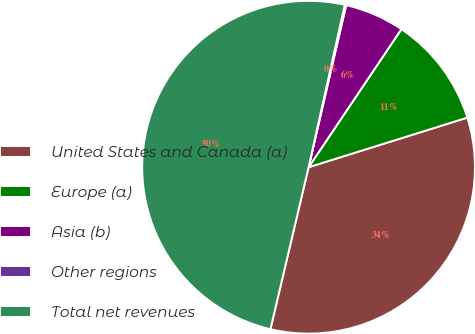Convert chart to OTSL. <chart><loc_0><loc_0><loc_500><loc_500><pie_chart><fcel>United States and Canada (a)<fcel>Europe (a)<fcel>Asia (b)<fcel>Other regions<fcel>Total net revenues<nl><fcel>33.51%<fcel>10.76%<fcel>5.79%<fcel>0.14%<fcel>49.81%<nl></chart> 